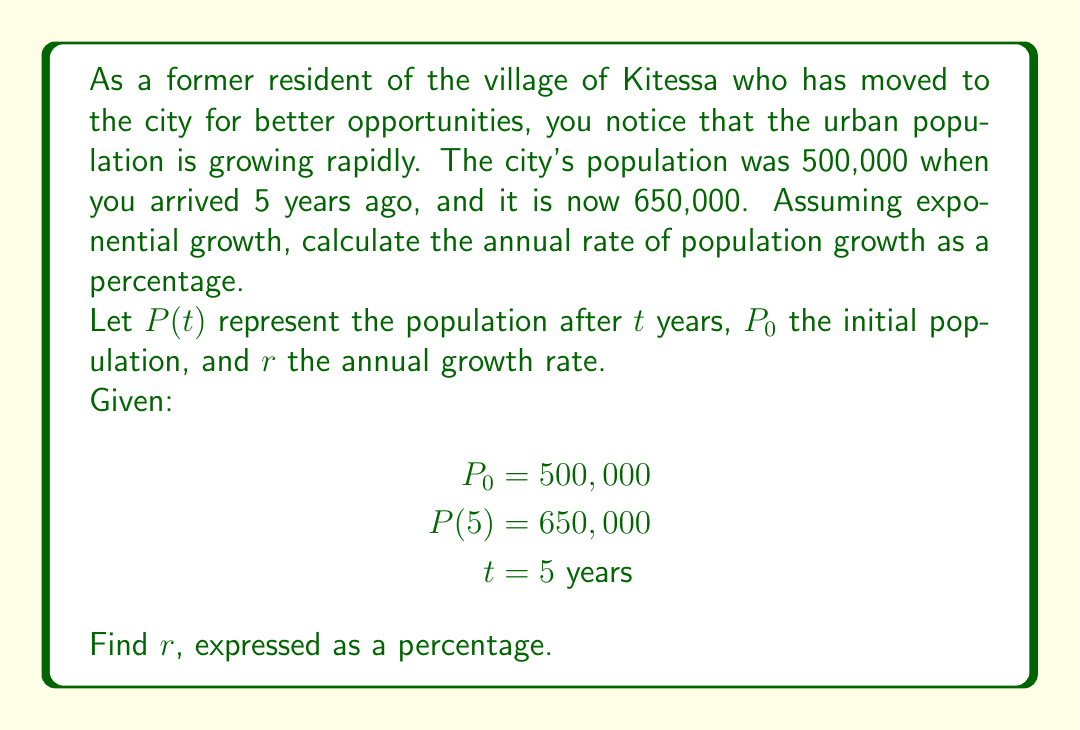Provide a solution to this math problem. To solve this problem, we'll use the exponential growth formula:

$$P(t) = P_0 \cdot e^{rt}$$

Where:
$P(t)$ is the population after time $t$
$P_0$ is the initial population
$e$ is Euler's number (approximately 2.71828)
$r$ is the growth rate (in decimal form)
$t$ is the time period

Let's plug in the known values:

$$650,000 = 500,000 \cdot e^{5r}$$

Now, let's solve for $r$:

1) Divide both sides by 500,000:
   $$\frac{650,000}{500,000} = e^{5r}$$

2) Simplify:
   $$1.3 = e^{5r}$$

3) Take the natural logarithm of both sides:
   $$\ln(1.3) = \ln(e^{5r})$$

4) Simplify the right side using the properties of logarithms:
   $$\ln(1.3) = 5r$$

5) Divide both sides by 5:
   $$\frac{\ln(1.3)}{5} = r$$

6) Calculate:
   $$r \approx 0.0524$$

7) Convert to a percentage:
   $$r \approx 5.24\%$$

Therefore, the annual population growth rate is approximately 5.24%.
Answer: The annual rate of population growth is approximately 5.24%. 